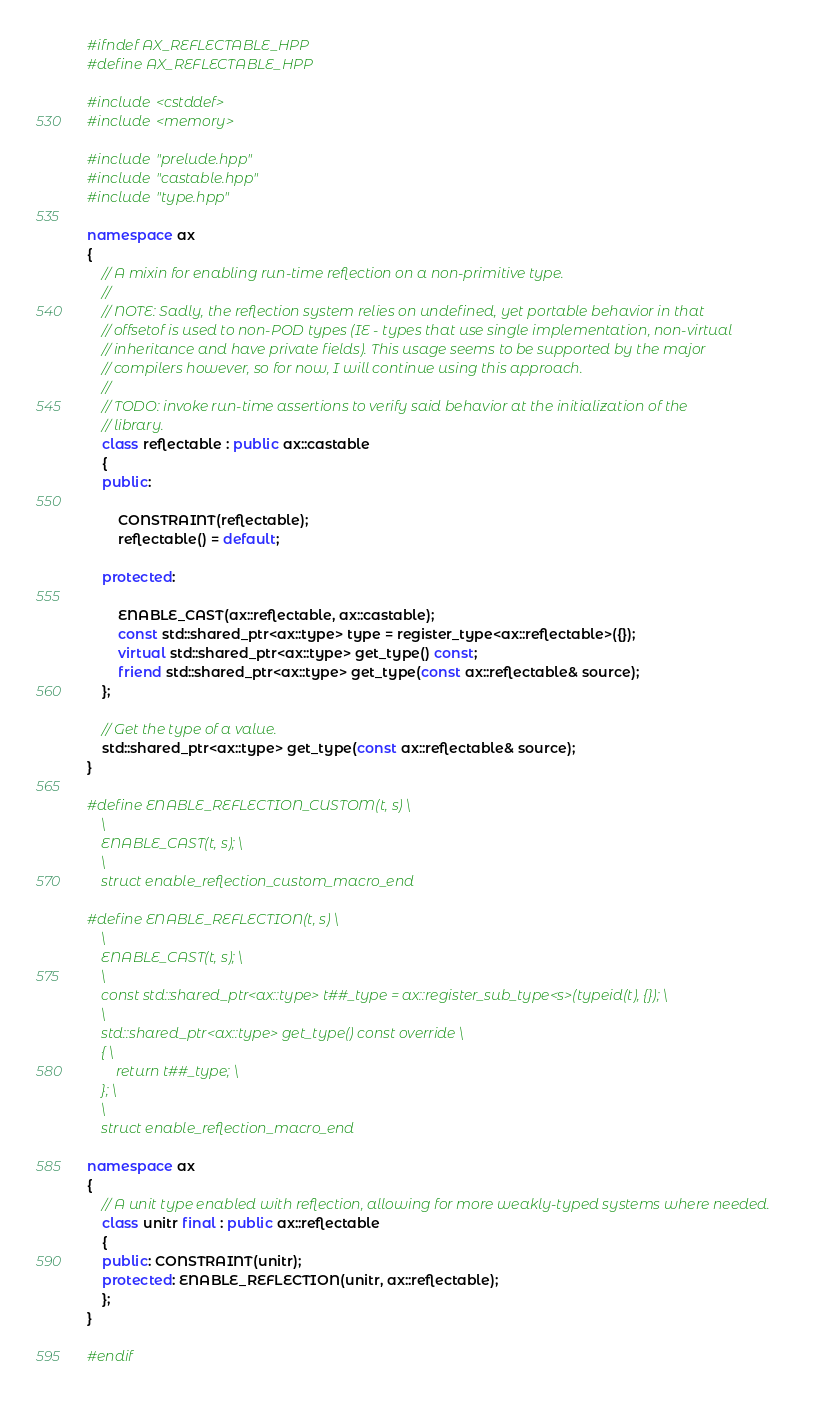<code> <loc_0><loc_0><loc_500><loc_500><_C++_>#ifndef AX_REFLECTABLE_HPP
#define AX_REFLECTABLE_HPP

#include <cstddef>
#include <memory>

#include "prelude.hpp"
#include "castable.hpp"
#include "type.hpp"

namespace ax
{
    // A mixin for enabling run-time reflection on a non-primitive type.
    //
    // NOTE: Sadly, the reflection system relies on undefined, yet portable behavior in that
    // offsetof is used to non-POD types (IE - types that use single implementation, non-virtual
    // inheritance and have private fields). This usage seems to be supported by the major
    // compilers however, so for now, I will continue using this approach.
    //
    // TODO: invoke run-time assertions to verify said behavior at the initialization of the
    // library.
    class reflectable : public ax::castable
    {
    public:

        CONSTRAINT(reflectable);
        reflectable() = default;

    protected:

        ENABLE_CAST(ax::reflectable, ax::castable);
        const std::shared_ptr<ax::type> type = register_type<ax::reflectable>({});
        virtual std::shared_ptr<ax::type> get_type() const;
        friend std::shared_ptr<ax::type> get_type(const ax::reflectable& source);
    };

    // Get the type of a value.
    std::shared_ptr<ax::type> get_type(const ax::reflectable& source);
}

#define ENABLE_REFLECTION_CUSTOM(t, s) \
    \
    ENABLE_CAST(t, s); \
    \
    struct enable_reflection_custom_macro_end

#define ENABLE_REFLECTION(t, s) \
    \
    ENABLE_CAST(t, s); \
    \
    const std::shared_ptr<ax::type> t##_type = ax::register_sub_type<s>(typeid(t), {}); \
    \
    std::shared_ptr<ax::type> get_type() const override \
    { \
        return t##_type; \
    }; \
    \
    struct enable_reflection_macro_end

namespace ax
{
    // A unit type enabled with reflection, allowing for more weakly-typed systems where needed.
    class unitr final : public ax::reflectable
    {
    public: CONSTRAINT(unitr);
    protected: ENABLE_REFLECTION(unitr, ax::reflectable);
    };
}

#endif
</code> 